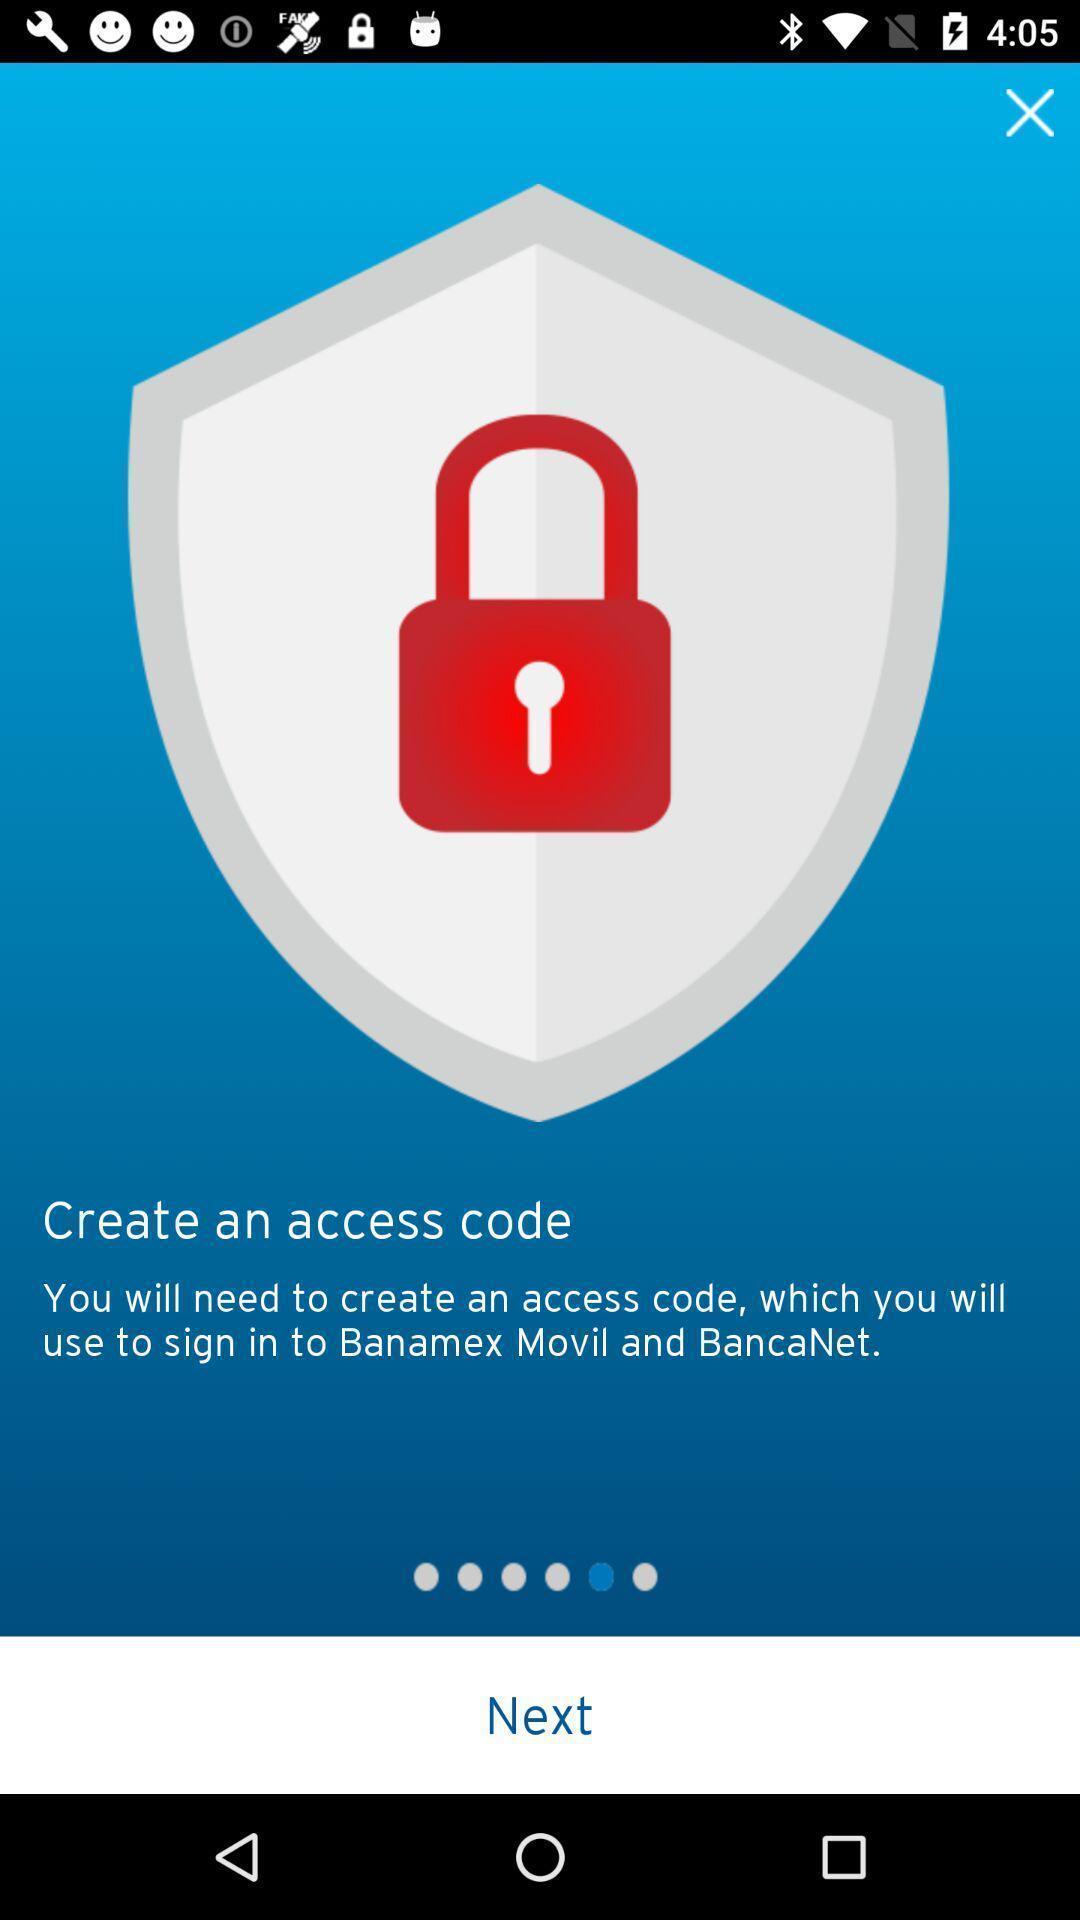Describe the key features of this screenshot. Page showing home page. 